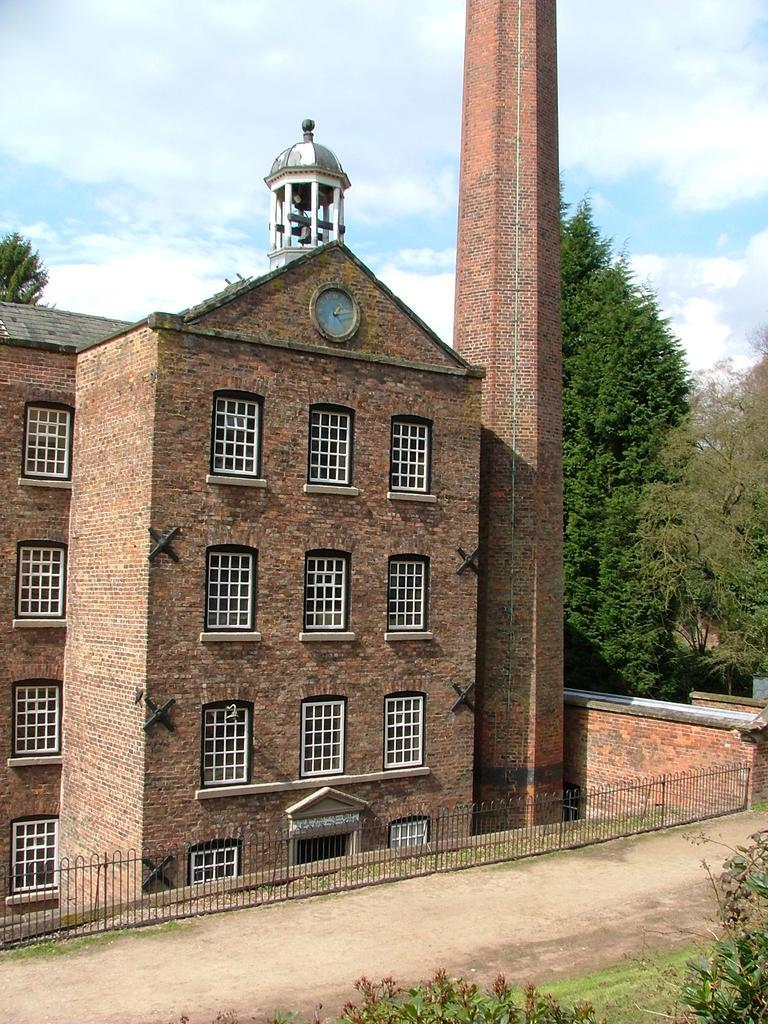What type of structures can be seen in the image? There are buildings in the image. What natural elements are present in the image? There are trees in the image. What type of barrier can be seen in the image? There is a fence in the image. What can be seen in the sky in the image? There are clouds in the image. What tall structure is present in the image? There is a tower in the image. What time-related object can be seen in the image? There is a clock in the image. Can you tell me how many police officers are visible in the image? There are no police officers present in the image. What type of animal is using the calculator in the image? There is no calculator or animal present in the image. 